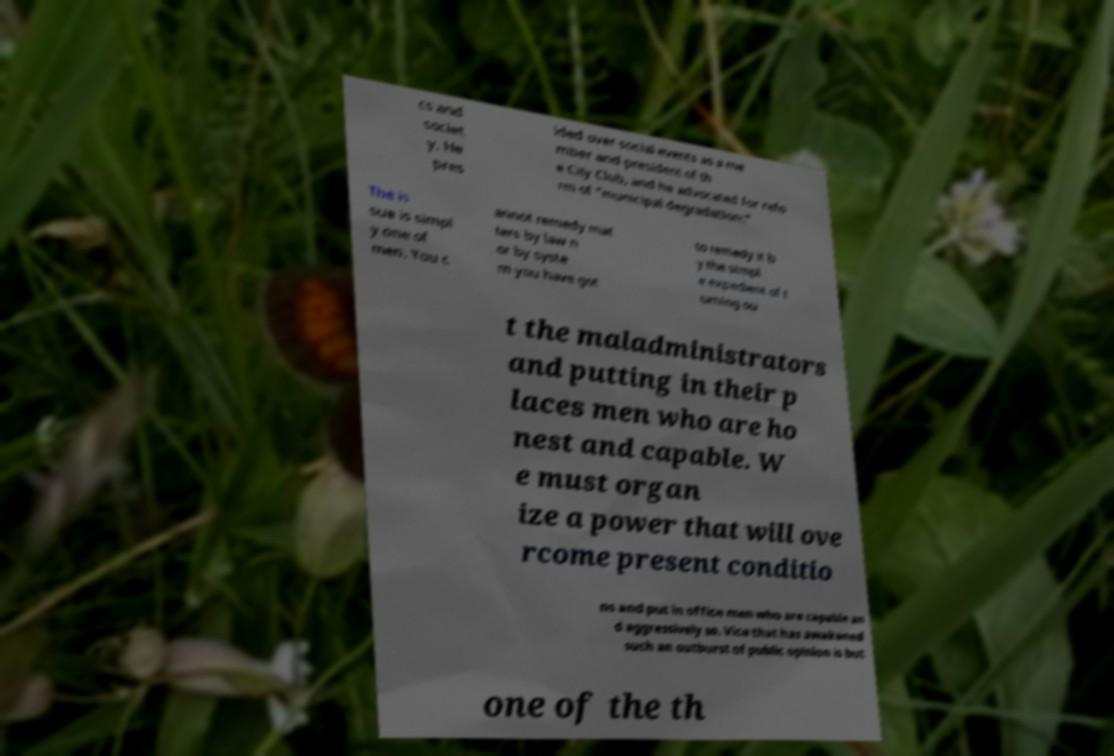Please read and relay the text visible in this image. What does it say? cs and societ y. He pres ided over social events as a me mber and president of th e City Club, and he advocated for refo rm of "municipal degradation:" The is sue is simpl y one of men. You c annot remedy mat ters by law n or by syste m you have got to remedy it b y the simpl e expedient of t urning ou t the maladministrators and putting in their p laces men who are ho nest and capable. W e must organ ize a power that will ove rcome present conditio ns and put in office men who are capable an d aggressively so. Vice that has awakened such an outburst of public opinion is but one of the th 